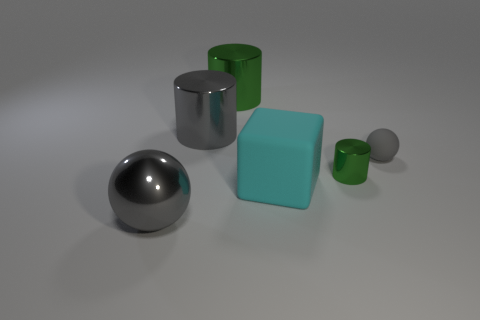What is the size of the other metallic cylinder that is the same color as the small metal cylinder?
Your answer should be very brief. Large. What shape is the metallic thing right of the green cylinder that is behind the tiny green metal cylinder?
Offer a very short reply. Cylinder. Are there any small metallic cylinders that are behind the green metallic object that is in front of the green metal cylinder on the left side of the tiny metallic object?
Your answer should be very brief. No. There is a ball that is the same size as the cyan cube; what color is it?
Offer a very short reply. Gray. There is a gray object that is in front of the gray cylinder and behind the big rubber object; what is its shape?
Offer a very short reply. Sphere. How big is the green cylinder that is in front of the gray object behind the tiny rubber sphere?
Keep it short and to the point. Small. How many big metallic cylinders have the same color as the tiny metal cylinder?
Ensure brevity in your answer.  1. What number of other things are the same size as the gray rubber thing?
Ensure brevity in your answer.  1. What size is the object that is to the left of the tiny green metal thing and right of the big green shiny cylinder?
Your answer should be very brief. Large. How many big objects are the same shape as the tiny green object?
Your response must be concise. 2. 